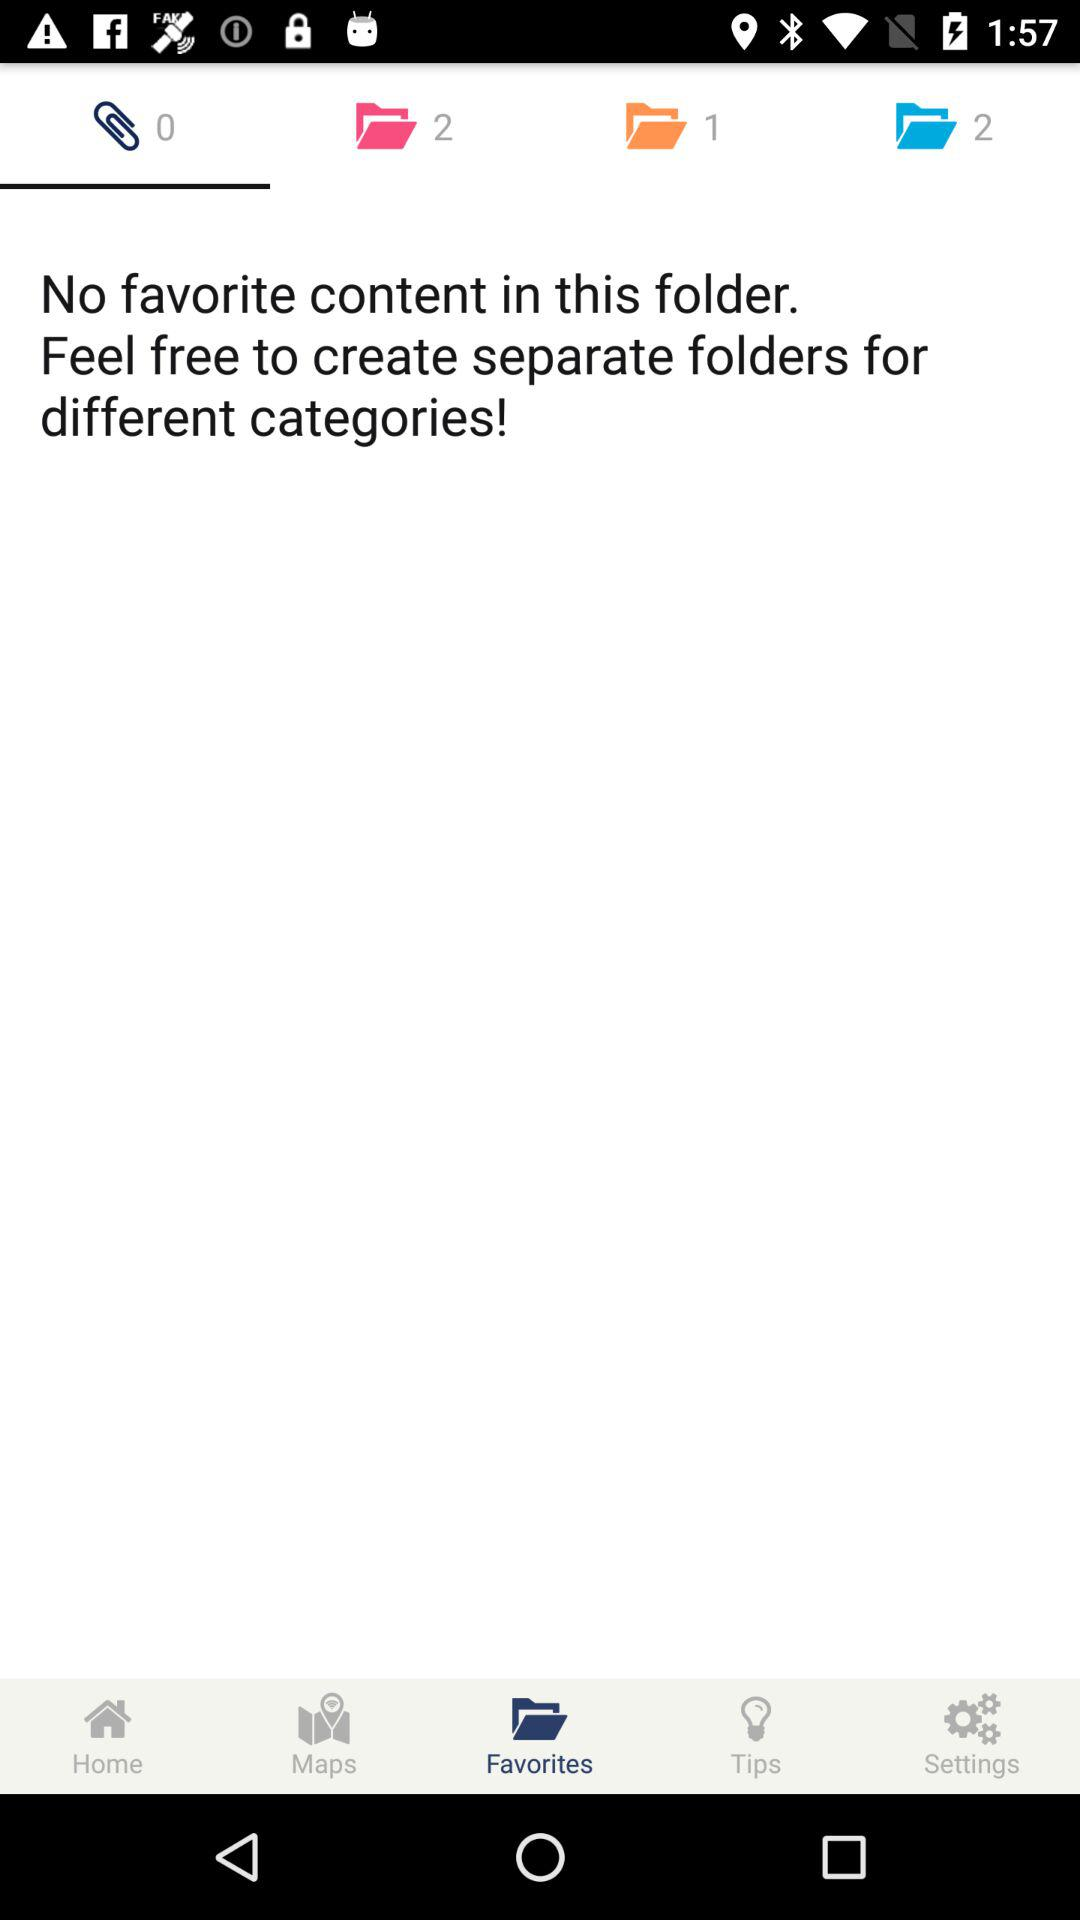How many favorites are in the folder? There are no favorites in the folder. 